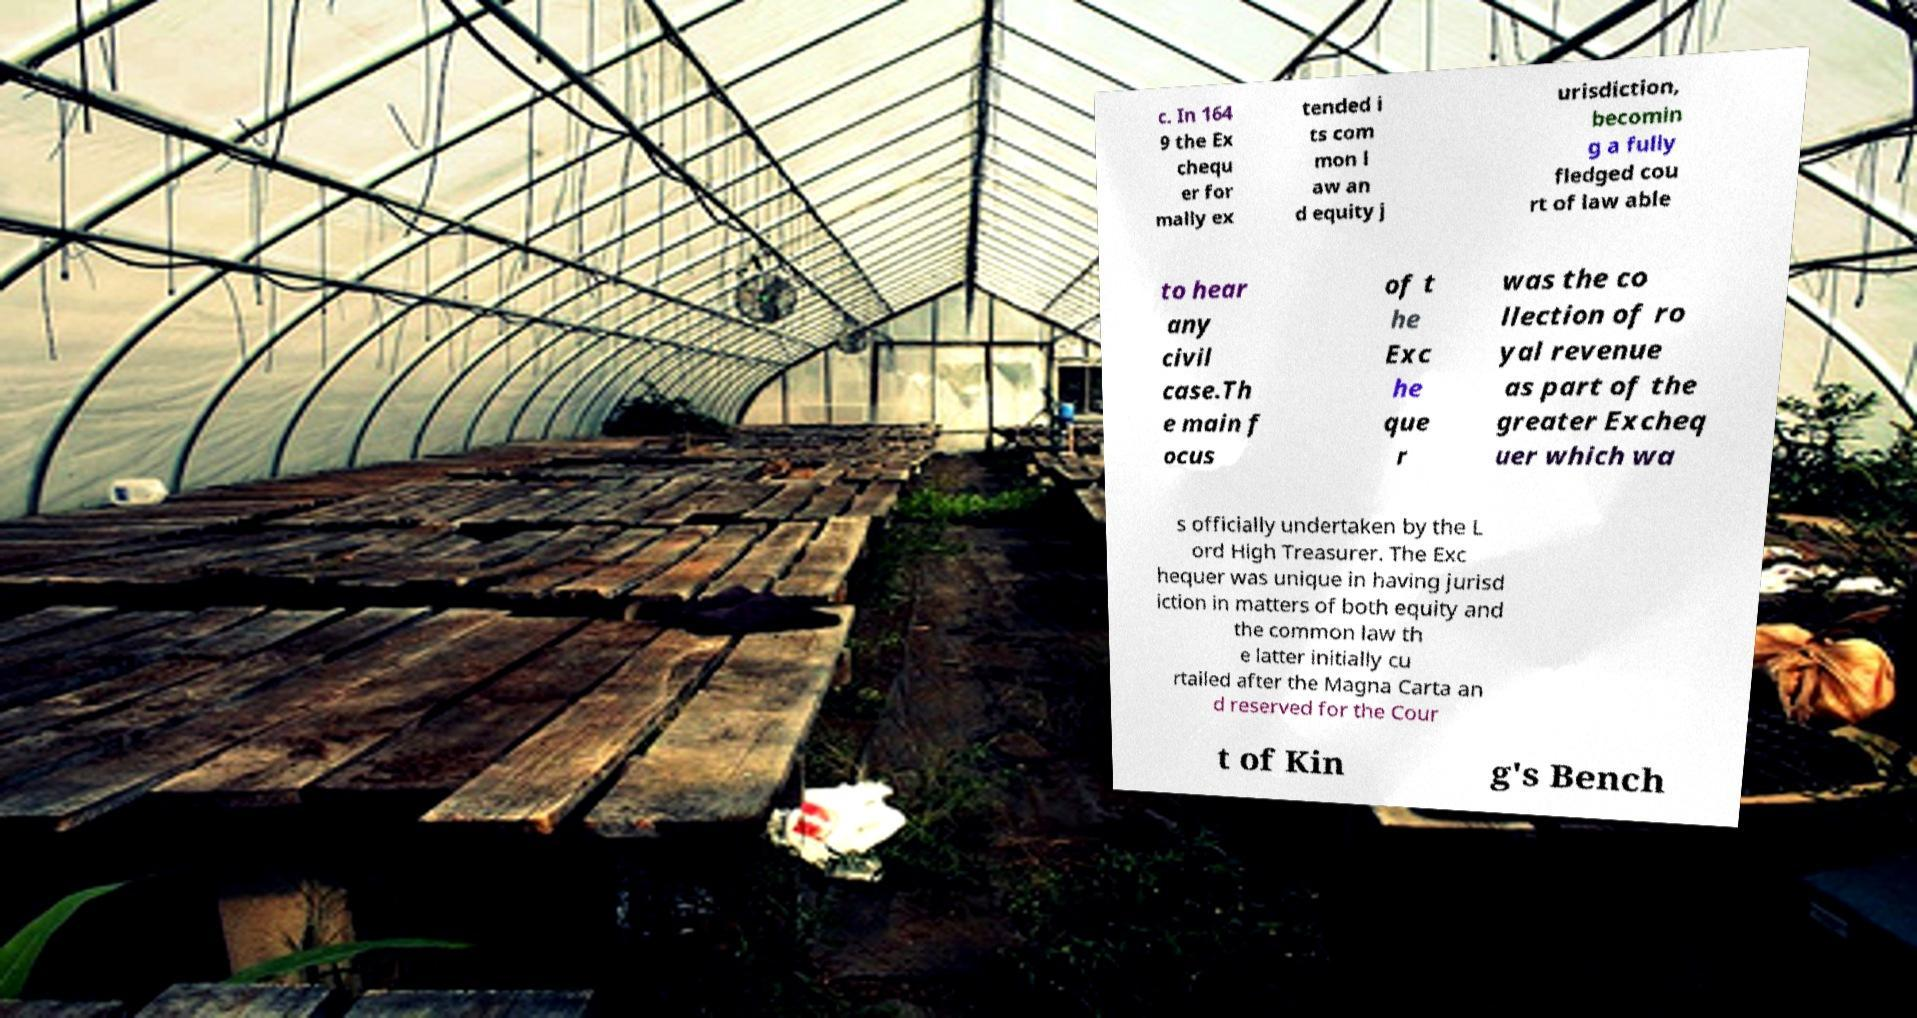Please read and relay the text visible in this image. What does it say? c. In 164 9 the Ex chequ er for mally ex tended i ts com mon l aw an d equity j urisdiction, becomin g a fully fledged cou rt of law able to hear any civil case.Th e main f ocus of t he Exc he que r was the co llection of ro yal revenue as part of the greater Excheq uer which wa s officially undertaken by the L ord High Treasurer. The Exc hequer was unique in having jurisd iction in matters of both equity and the common law th e latter initially cu rtailed after the Magna Carta an d reserved for the Cour t of Kin g's Bench 